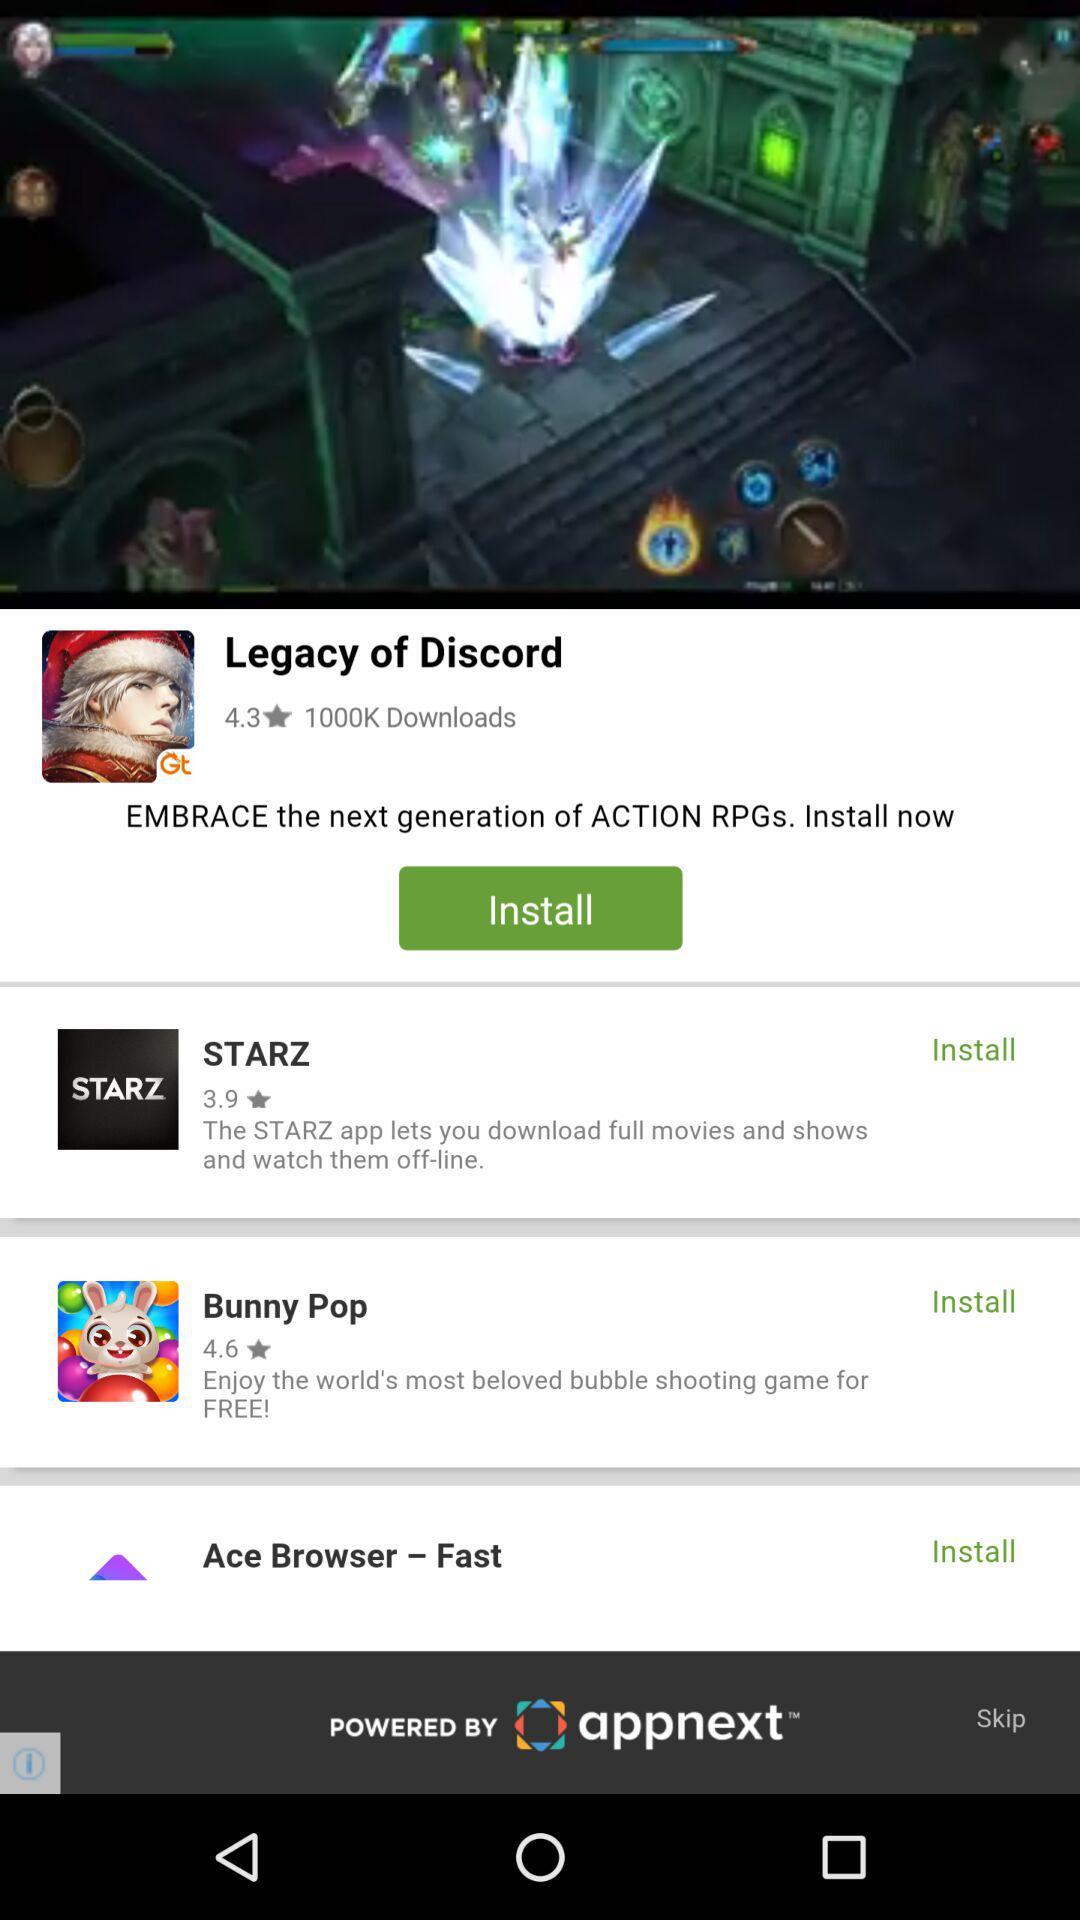How many people have downloaded "Legacy of Discord"? "Legacy of Discord" has been downloaded by 1,000,000 people. 